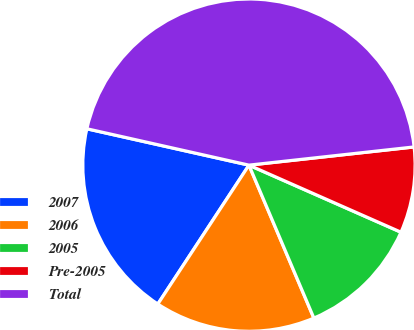<chart> <loc_0><loc_0><loc_500><loc_500><pie_chart><fcel>2007<fcel>2006<fcel>2005<fcel>Pre-2005<fcel>Total<nl><fcel>19.27%<fcel>15.63%<fcel>12.0%<fcel>8.36%<fcel>44.74%<nl></chart> 